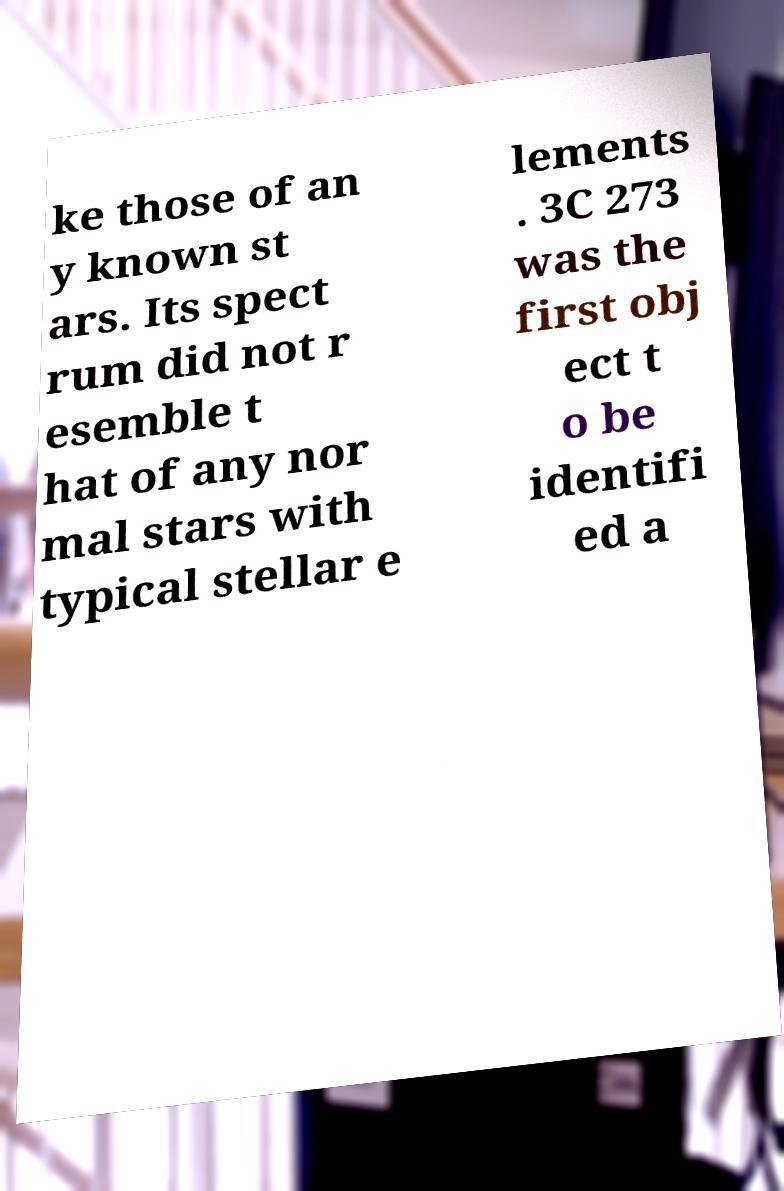Please identify and transcribe the text found in this image. ke those of an y known st ars. Its spect rum did not r esemble t hat of any nor mal stars with typical stellar e lements . 3C 273 was the first obj ect t o be identifi ed a 